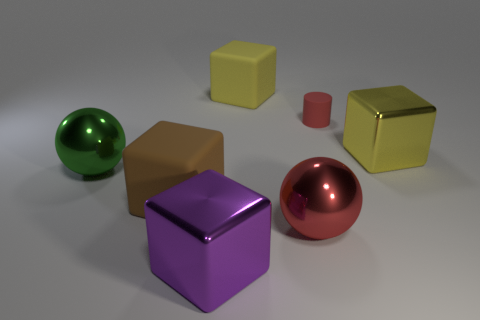Is there anything else that is the same size as the cylinder?
Give a very brief answer. No. The big purple metal object has what shape?
Offer a terse response. Cube. What shape is the matte object that is both on the left side of the big red shiny ball and right of the brown thing?
Your answer should be very brief. Cube. There is another big cube that is made of the same material as the big brown block; what color is it?
Provide a short and direct response. Yellow. What is the shape of the red thing behind the shiny sphere on the left side of the big matte block behind the red rubber cylinder?
Offer a very short reply. Cylinder. The brown block has what size?
Ensure brevity in your answer.  Large. There is a brown thing that is the same material as the cylinder; what shape is it?
Ensure brevity in your answer.  Cube. Are there fewer red cylinders to the left of the big green metallic sphere than green metal spheres?
Provide a succinct answer. Yes. What is the color of the big rubber block in front of the green object?
Make the answer very short. Brown. There is a big ball that is the same color as the tiny rubber cylinder; what is its material?
Offer a terse response. Metal. 